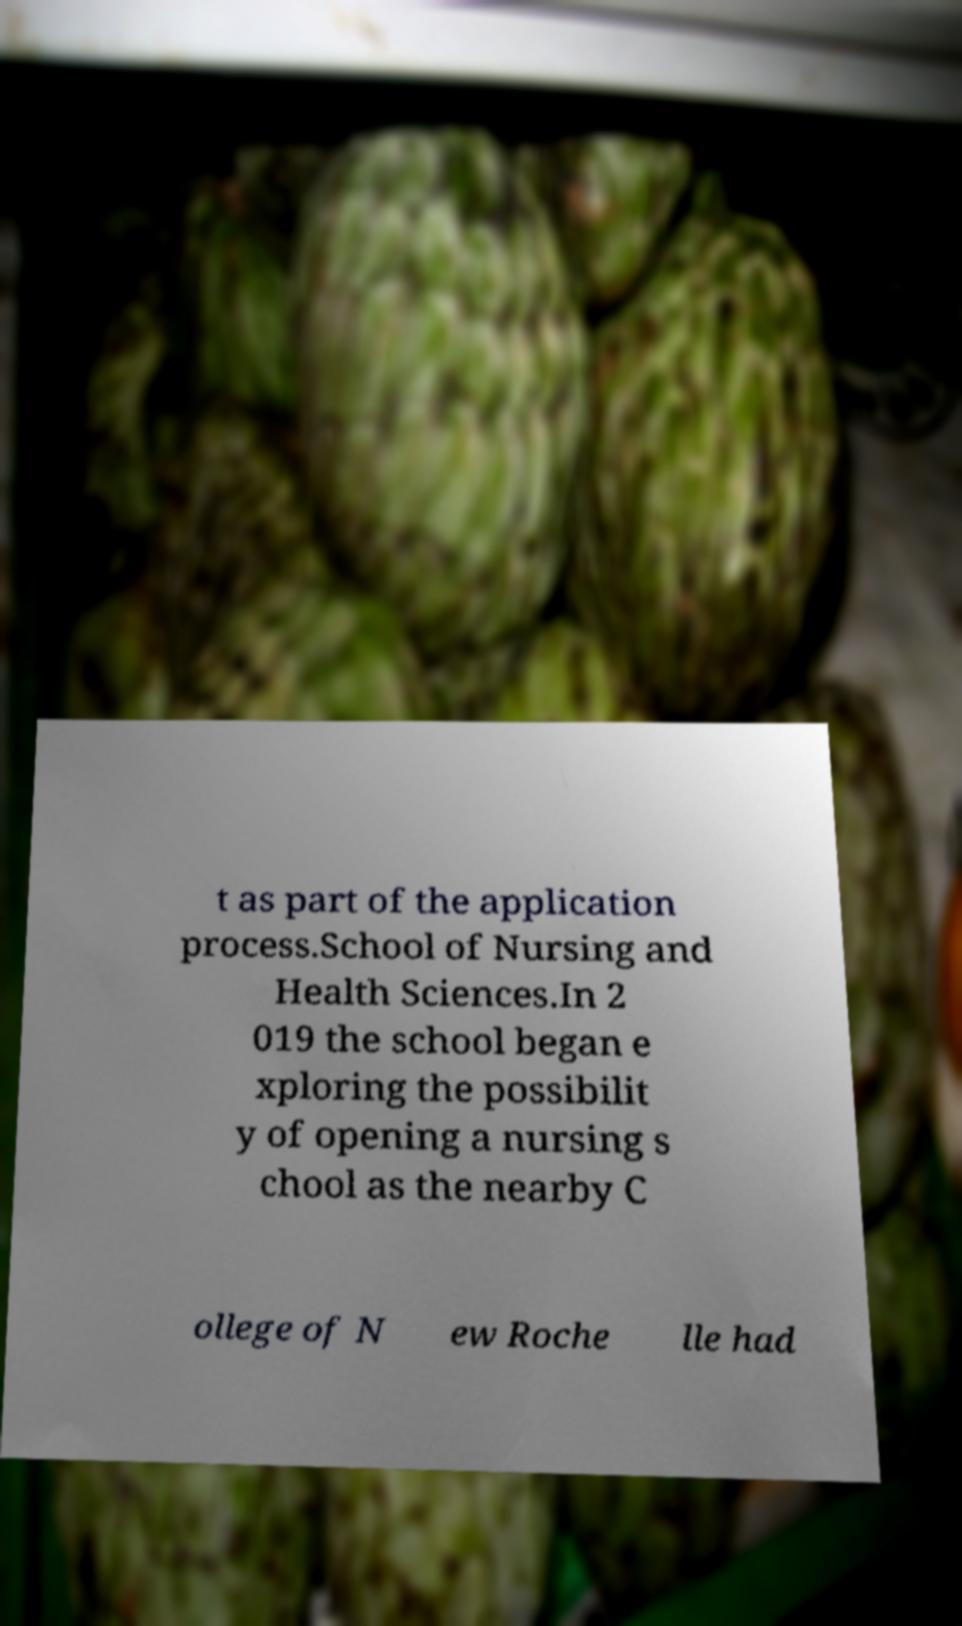There's text embedded in this image that I need extracted. Can you transcribe it verbatim? t as part of the application process.School of Nursing and Health Sciences.In 2 019 the school began e xploring the possibilit y of opening a nursing s chool as the nearby C ollege of N ew Roche lle had 